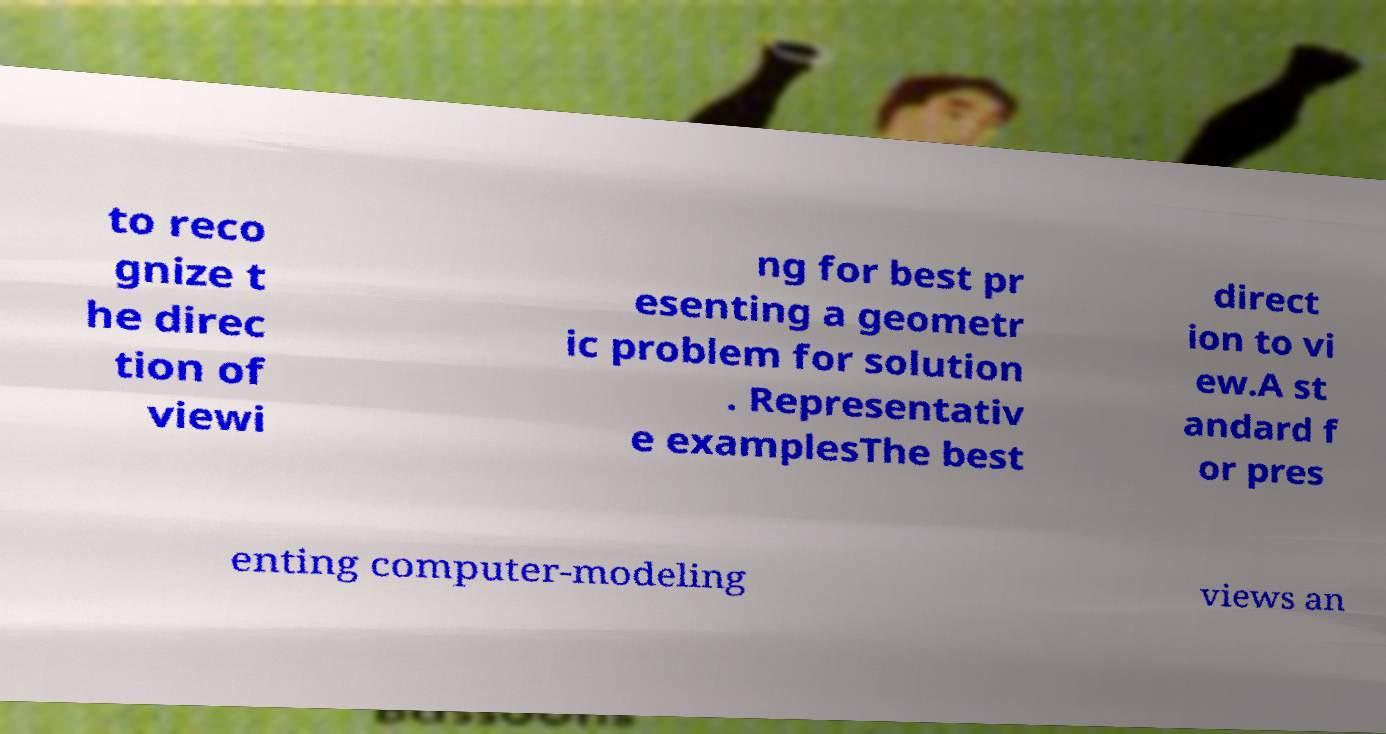Please identify and transcribe the text found in this image. to reco gnize t he direc tion of viewi ng for best pr esenting a geometr ic problem for solution . Representativ e examplesThe best direct ion to vi ew.A st andard f or pres enting computer-modeling views an 